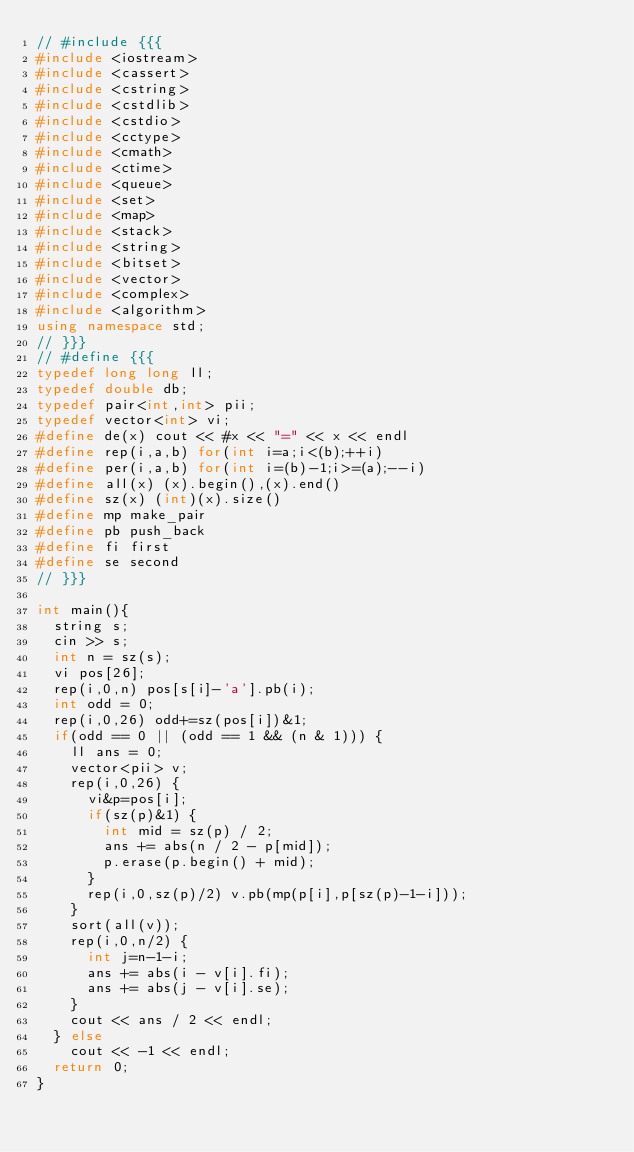Convert code to text. <code><loc_0><loc_0><loc_500><loc_500><_C++_>// #include {{{
#include <iostream>
#include <cassert>
#include <cstring>
#include <cstdlib>
#include <cstdio>
#include <cctype>
#include <cmath>
#include <ctime>
#include <queue>
#include <set>
#include <map>
#include <stack>
#include <string>
#include <bitset>
#include <vector>
#include <complex>
#include <algorithm>
using namespace std;
// }}}
// #define {{{
typedef long long ll;
typedef double db;
typedef pair<int,int> pii;
typedef vector<int> vi;
#define de(x) cout << #x << "=" << x << endl
#define rep(i,a,b) for(int i=a;i<(b);++i)
#define per(i,a,b) for(int i=(b)-1;i>=(a);--i)
#define all(x) (x).begin(),(x).end()
#define sz(x) (int)(x).size()
#define mp make_pair
#define pb push_back
#define fi first
#define se second
// }}}

int main(){
  string s;
  cin >> s;
  int n = sz(s);
  vi pos[26];
  rep(i,0,n) pos[s[i]-'a'].pb(i);
  int odd = 0;
  rep(i,0,26) odd+=sz(pos[i])&1;
  if(odd == 0 || (odd == 1 && (n & 1))) {
    ll ans = 0;
    vector<pii> v;
    rep(i,0,26) {
      vi&p=pos[i];
      if(sz(p)&1) {
        int mid = sz(p) / 2;
        ans += abs(n / 2 - p[mid]);
        p.erase(p.begin() + mid);
      }
      rep(i,0,sz(p)/2) v.pb(mp(p[i],p[sz(p)-1-i]));
    }
    sort(all(v));
    rep(i,0,n/2) {
      int j=n-1-i;
      ans += abs(i - v[i].fi);
      ans += abs(j - v[i].se);
    }
    cout << ans / 2 << endl;
  } else
    cout << -1 << endl;
  return 0;
}
</code> 